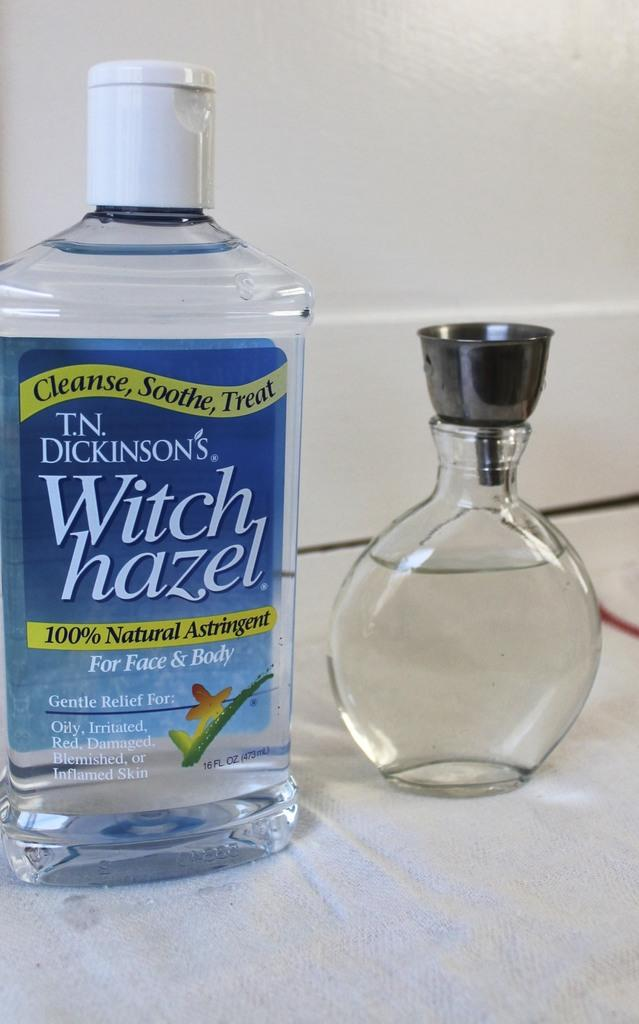<image>
Share a concise interpretation of the image provided. Bottle of Witch hazel by T.N. Dickinson's next to a clear bottle. 